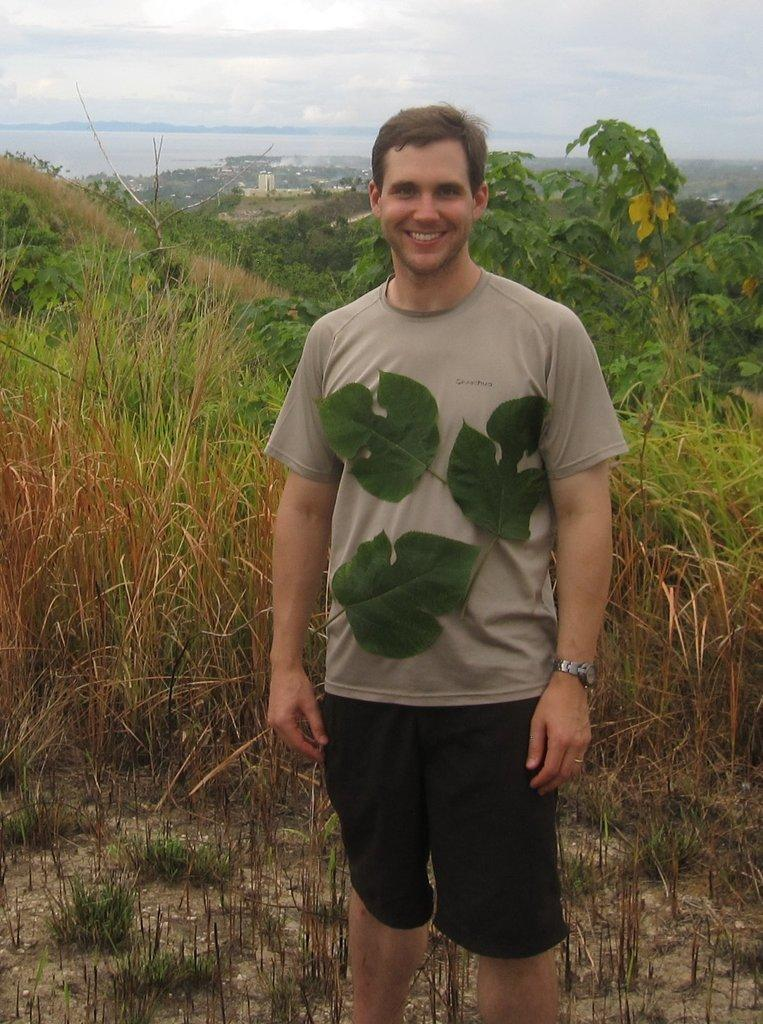What is the main subject of the image? There is a person standing in the image. What is unique about the person's clothing? The person has leaves on their t-shirt. What type of natural environment is visible in the backdrop of the image? There is grass and plants in the backdrop of the image. How would you describe the weather based on the image? The sky is clear in the image, suggesting good weather. What type of plate is being used to serve the food in the image? There is no plate or food present in the image; it features a person with leaves on their t-shirt in a natural environment. What is the aftermath of the event in the image? There is no event or aftermath depicted in the image. 